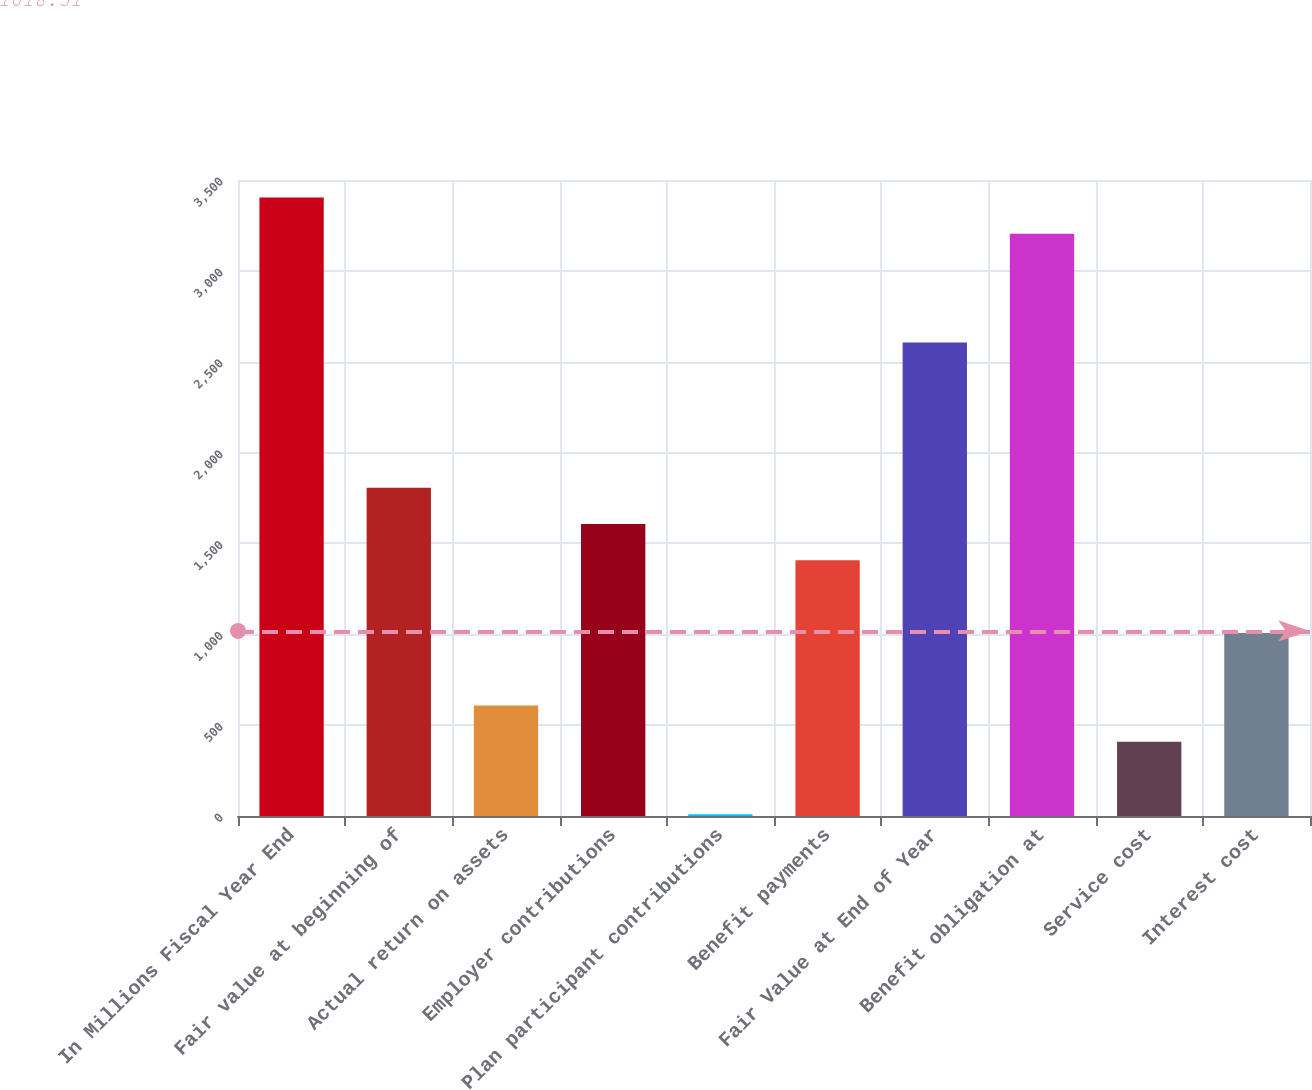<chart> <loc_0><loc_0><loc_500><loc_500><bar_chart><fcel>In Millions Fiscal Year End<fcel>Fair value at beginning of<fcel>Actual return on assets<fcel>Employer contributions<fcel>Plan participant contributions<fcel>Benefit payments<fcel>Fair Value at End of Year<fcel>Benefit obligation at<fcel>Service cost<fcel>Interest cost<nl><fcel>3403.9<fcel>1806.3<fcel>608.1<fcel>1606.6<fcel>9<fcel>1406.9<fcel>2605.1<fcel>3204.2<fcel>408.4<fcel>1007.5<nl></chart> 